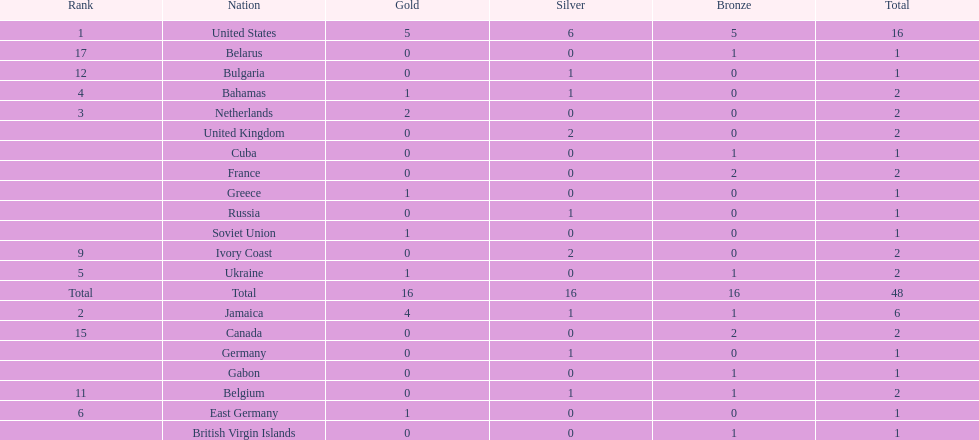Which countries won at least 3 silver medals? United States. 